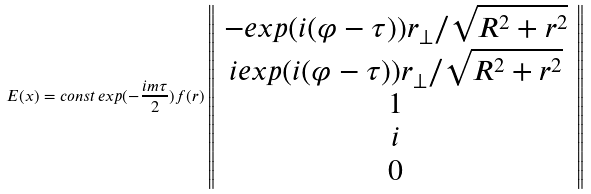<formula> <loc_0><loc_0><loc_500><loc_500>E ( x ) = c o n s t \, e x p ( - \frac { i m \tau } { 2 } ) f ( r ) \left \| \begin{array} { c } - e x p ( i ( \varphi - \tau ) ) r _ { \bot } / \sqrt { R ^ { 2 } + r ^ { 2 } } \\ i e x p ( i ( \varphi - \tau ) ) r _ { \bot } / \sqrt { R ^ { 2 } + r ^ { 2 } } \\ 1 \\ i \\ 0 \end{array} \right \|</formula> 